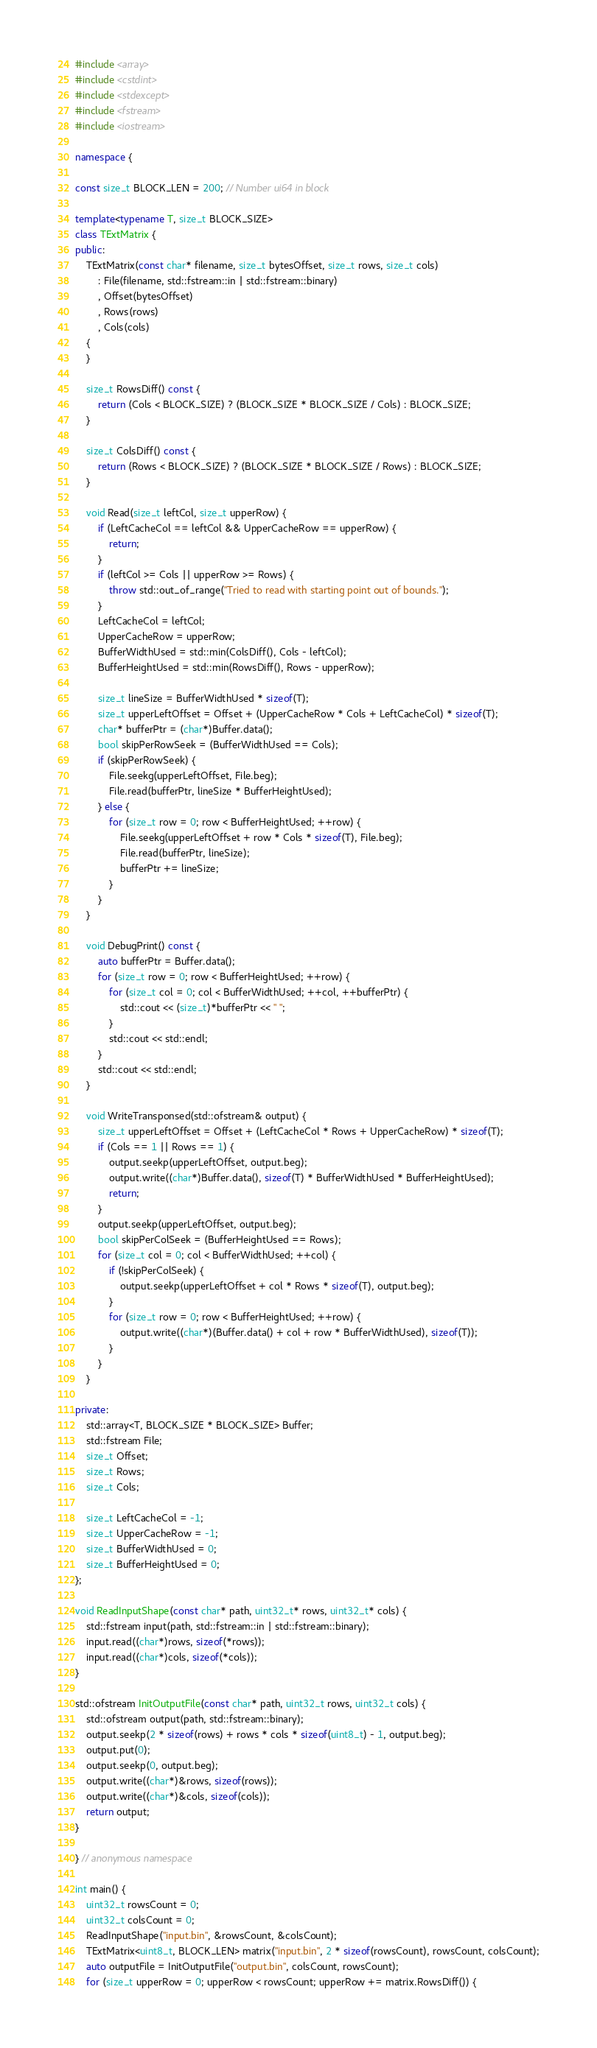Convert code to text. <code><loc_0><loc_0><loc_500><loc_500><_C++_>#include <array>
#include <cstdint>
#include <stdexcept>
#include <fstream>
#include <iostream>

namespace {

const size_t BLOCK_LEN = 200; // Number ui64 in block

template<typename T, size_t BLOCK_SIZE>
class TExtMatrix {
public:
    TExtMatrix(const char* filename, size_t bytesOffset, size_t rows, size_t cols)
        : File(filename, std::fstream::in | std::fstream::binary)
        , Offset(bytesOffset)
        , Rows(rows)
        , Cols(cols)
    {
    }

    size_t RowsDiff() const {
        return (Cols < BLOCK_SIZE) ? (BLOCK_SIZE * BLOCK_SIZE / Cols) : BLOCK_SIZE;
    }

    size_t ColsDiff() const {
        return (Rows < BLOCK_SIZE) ? (BLOCK_SIZE * BLOCK_SIZE / Rows) : BLOCK_SIZE;
    }

    void Read(size_t leftCol, size_t upperRow) {
        if (LeftCacheCol == leftCol && UpperCacheRow == upperRow) {
            return;
        }
        if (leftCol >= Cols || upperRow >= Rows) {
            throw std::out_of_range("Tried to read with starting point out of bounds.");
        }
        LeftCacheCol = leftCol;
        UpperCacheRow = upperRow;
        BufferWidthUsed = std::min(ColsDiff(), Cols - leftCol);
        BufferHeightUsed = std::min(RowsDiff(), Rows - upperRow);

        size_t lineSize = BufferWidthUsed * sizeof(T);
        size_t upperLeftOffset = Offset + (UpperCacheRow * Cols + LeftCacheCol) * sizeof(T);
        char* bufferPtr = (char*)Buffer.data();
        bool skipPerRowSeek = (BufferWidthUsed == Cols);
        if (skipPerRowSeek) {
            File.seekg(upperLeftOffset, File.beg);
            File.read(bufferPtr, lineSize * BufferHeightUsed);
        } else {
            for (size_t row = 0; row < BufferHeightUsed; ++row) {
                File.seekg(upperLeftOffset + row * Cols * sizeof(T), File.beg);
                File.read(bufferPtr, lineSize);
                bufferPtr += lineSize;
            }
        }
    }

    void DebugPrint() const {
        auto bufferPtr = Buffer.data();
        for (size_t row = 0; row < BufferHeightUsed; ++row) {
            for (size_t col = 0; col < BufferWidthUsed; ++col, ++bufferPtr) {
                std::cout << (size_t)*bufferPtr << " ";
            }
            std::cout << std::endl;
        }
        std::cout << std::endl;
    }

    void WriteTransponsed(std::ofstream& output) {
        size_t upperLeftOffset = Offset + (LeftCacheCol * Rows + UpperCacheRow) * sizeof(T);
        if (Cols == 1 || Rows == 1) {
            output.seekp(upperLeftOffset, output.beg);
            output.write((char*)Buffer.data(), sizeof(T) * BufferWidthUsed * BufferHeightUsed);
            return;
        }
        output.seekp(upperLeftOffset, output.beg);
        bool skipPerColSeek = (BufferHeightUsed == Rows);
        for (size_t col = 0; col < BufferWidthUsed; ++col) {
            if (!skipPerColSeek) {
                output.seekp(upperLeftOffset + col * Rows * sizeof(T), output.beg);
            }
            for (size_t row = 0; row < BufferHeightUsed; ++row) {
                output.write((char*)(Buffer.data() + col + row * BufferWidthUsed), sizeof(T));
            }
        }
    }

private:
    std::array<T, BLOCK_SIZE * BLOCK_SIZE> Buffer;
    std::fstream File;
    size_t Offset;
    size_t Rows;
    size_t Cols;

    size_t LeftCacheCol = -1;
    size_t UpperCacheRow = -1;
    size_t BufferWidthUsed = 0;
    size_t BufferHeightUsed = 0;
};

void ReadInputShape(const char* path, uint32_t* rows, uint32_t* cols) {
    std::fstream input(path, std::fstream::in | std::fstream::binary);
    input.read((char*)rows, sizeof(*rows));
    input.read((char*)cols, sizeof(*cols));
}

std::ofstream InitOutputFile(const char* path, uint32_t rows, uint32_t cols) {
    std::ofstream output(path, std::fstream::binary);
    output.seekp(2 * sizeof(rows) + rows * cols * sizeof(uint8_t) - 1, output.beg);
    output.put(0);
    output.seekp(0, output.beg);
    output.write((char*)&rows, sizeof(rows));
    output.write((char*)&cols, sizeof(cols));
    return output;
}

} // anonymous namespace

int main() {
    uint32_t rowsCount = 0;
    uint32_t colsCount = 0;
    ReadInputShape("input.bin", &rowsCount, &colsCount);
    TExtMatrix<uint8_t, BLOCK_LEN> matrix("input.bin", 2 * sizeof(rowsCount), rowsCount, colsCount);
    auto outputFile = InitOutputFile("output.bin", colsCount, rowsCount);
    for (size_t upperRow = 0; upperRow < rowsCount; upperRow += matrix.RowsDiff()) {</code> 